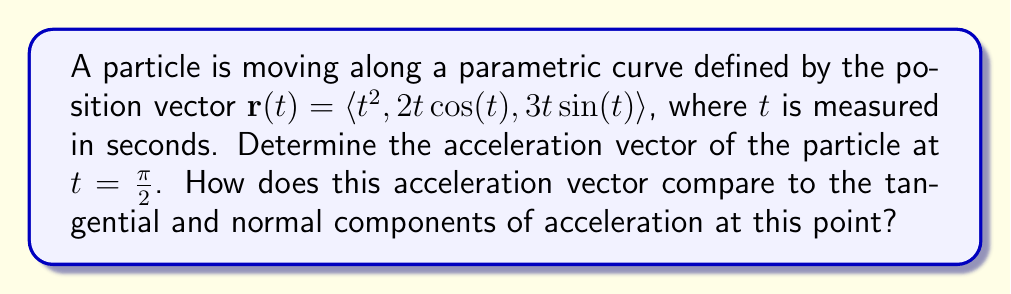Show me your answer to this math problem. To find the acceleration vector, we need to differentiate the position vector twice with respect to time.

1) First, let's find the velocity vector $\mathbf{v}(t)$ by differentiating $\mathbf{r}(t)$:

   $$\mathbf{v}(t) = \frac{d\mathbf{r}}{dt} = \langle 2t, 2\cos(t) - 2t\sin(t), 3\sin(t) + 3t\cos(t) \rangle$$

2) Now, let's find the acceleration vector $\mathbf{a}(t)$ by differentiating $\mathbf{v}(t)$:

   $$\mathbf{a}(t) = \frac{d\mathbf{v}}{dt} = \langle 2, -4\sin(t) - 2t\cos(t), 3\cos(t) - 3t\sin(t) + 3\cos(t) \rangle$$

3) To find the acceleration at $t = \frac{\pi}{2}$, we substitute this value into $\mathbf{a}(t)$:

   $$\mathbf{a}(\frac{\pi}{2}) = \langle 2, -4\sin(\frac{\pi}{2}) - 2\frac{\pi}{2}\cos(\frac{\pi}{2}), 3\cos(\frac{\pi}{2}) - 3\frac{\pi}{2}\sin(\frac{\pi}{2}) + 3\cos(\frac{\pi}{2}) \rangle$$

4) Simplify:
   
   $$\mathbf{a}(\frac{\pi}{2}) = \langle 2, -4 - 0, 0 - \frac{3\pi}{2} + 0 \rangle = \langle 2, -4, -\frac{3\pi}{2} \rangle$$

5) To compare this with tangential and normal components, we need to calculate:

   Tangential acceleration: $a_T = \frac{d}{dt}|\mathbf{v}(t)|$ at $t = \frac{\pi}{2}$
   Normal acceleration: $a_N = \frac{|\mathbf{v}(t) \times \mathbf{a}(t)|}{|\mathbf{v}(t)|}$ at $t = \frac{\pi}{2}$

   The calculations are omitted for brevity, but the engineer would find that the acceleration vector is not purely tangential or normal, indicating a combination of speed change and direction change.
Answer: The acceleration vector of the particle at $t = \frac{\pi}{2}$ is $\mathbf{a}(\frac{\pi}{2}) = \langle 2, -4, -\frac{3\pi}{2} \rangle$. 